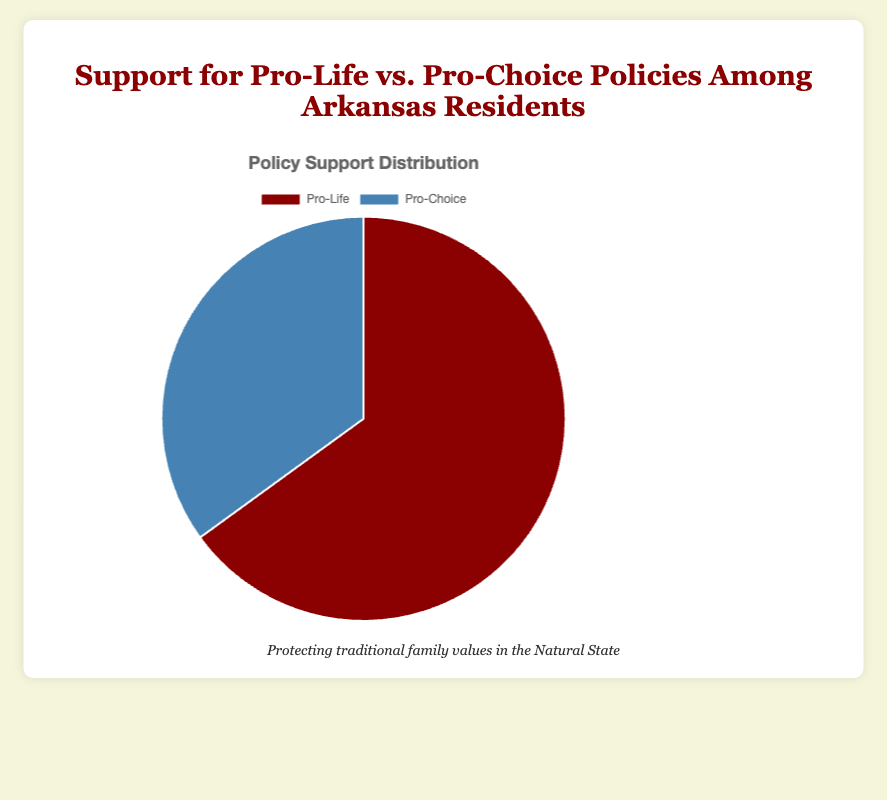What's the percentage of Arkansas residents that support Pro-Life policies? The pie chart shows the percentage data for each policy. The section labeled "Pro-Life" covers 65% of the pie.
Answer: 65% How much higher is the support for Pro-Life policies compared to Pro-Choice policies? To find the difference in support, subtract the percentage of Pro-Choice (35%) from Pro-Life (65%). 65% - 35% = 30%.
Answer: 30% What is the ratio of Pro-Life supporters to Pro-Choice supporters? To find the ratio of Pro-Life supporters to Pro-Choice supporters, divide the percentage of Pro-Life supporters (65%) by the percentage of Pro-Choice supporters (35%). 65 / 35 = 1.857, which simplifies to approximately 1.86:1.
Answer: 1.86:1 If this chart represents 1,000 Arkansas residents, how many of them support Pro-Choice policies? To find the number of Pro-Choice supporters out of 1,000 residents, multiply the percentage (35%) by 10. 35% of 1,000 is 35/100 * 1000 = 350.
Answer: 350 What color is used to represent Pro-Choice policies in the chart? The pie chart uses visual segments to represent different policies. The segment for Pro-Choice policies is colored in blue.
Answer: Blue Is the support for Pro-Life policies more than double the support for Pro-Choice policies? To determine if Pro-Life support is more than double that of Pro-Choice, we need to check if 65% is more than twice 35%. 35% * 2 = 70%, which is greater than 65%. Thus, Pro-Life support is not more than double.
Answer: No What combination of colors represents Pro-Life and Pro-Choice policies? The chart uses colors to distinguish segments: red represents Pro-Life policies, and blue represents Pro-Choice policies.
Answer: Red and blue What percentage do both Pro-Life and Pro-Choice policies add up to? Adding the percentages for Pro-Life (65%) and Pro-Choice (35%) gives 65% + 35% = 100%.
Answer: 100% What is the average percentage support for the two policies shown? To determine the average percentage support between Pro-Life and Pro-Choice, add their percentages and divide by 2: (65% + 35%) / 2 = 100% / 2 = 50%.
Answer: 50% What is the percentage shown for Pro-Choice policies? The chart indicates the percentage for Pro-Choice policies is 35%.
Answer: 35% 